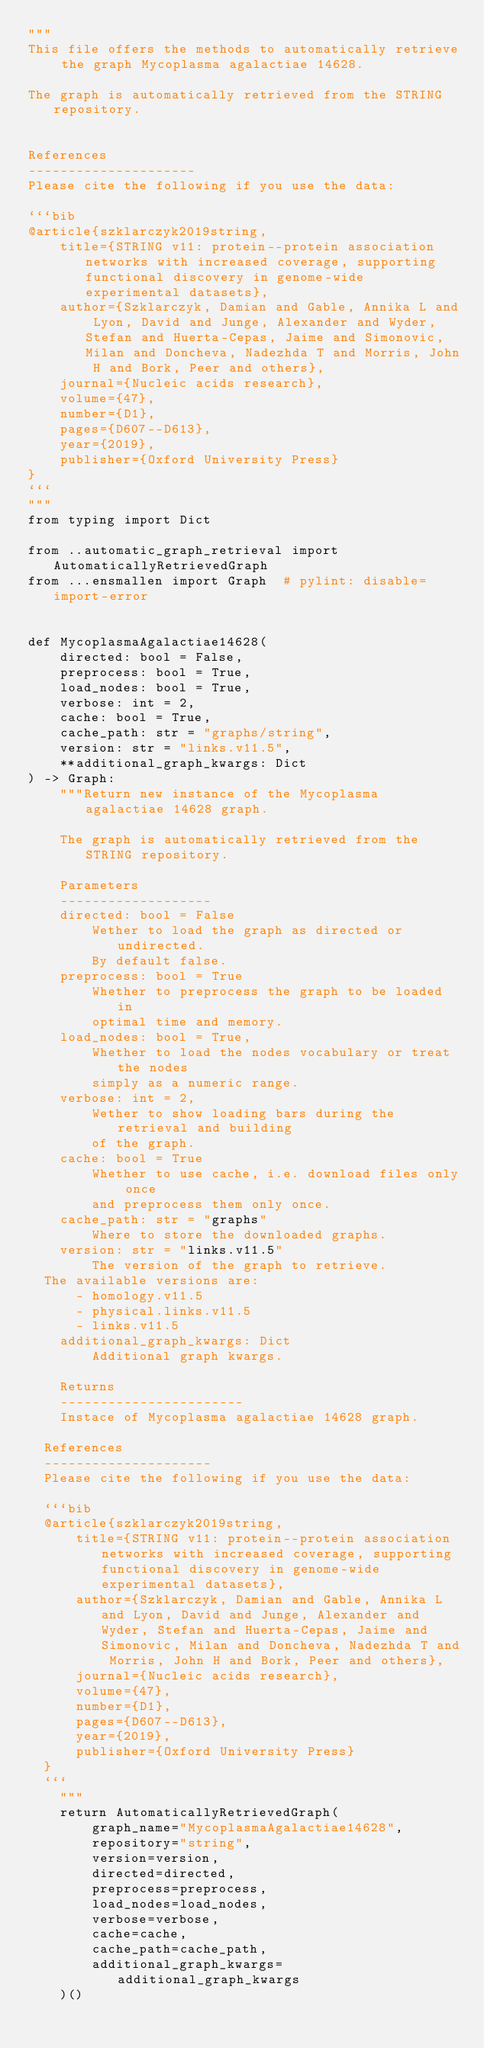Convert code to text. <code><loc_0><loc_0><loc_500><loc_500><_Python_>"""
This file offers the methods to automatically retrieve the graph Mycoplasma agalactiae 14628.

The graph is automatically retrieved from the STRING repository. 


References
---------------------
Please cite the following if you use the data:

```bib
@article{szklarczyk2019string,
    title={STRING v11: protein--protein association networks with increased coverage, supporting functional discovery in genome-wide experimental datasets},
    author={Szklarczyk, Damian and Gable, Annika L and Lyon, David and Junge, Alexander and Wyder, Stefan and Huerta-Cepas, Jaime and Simonovic, Milan and Doncheva, Nadezhda T and Morris, John H and Bork, Peer and others},
    journal={Nucleic acids research},
    volume={47},
    number={D1},
    pages={D607--D613},
    year={2019},
    publisher={Oxford University Press}
}
```
"""
from typing import Dict

from ..automatic_graph_retrieval import AutomaticallyRetrievedGraph
from ...ensmallen import Graph  # pylint: disable=import-error


def MycoplasmaAgalactiae14628(
    directed: bool = False,
    preprocess: bool = True,
    load_nodes: bool = True,
    verbose: int = 2,
    cache: bool = True,
    cache_path: str = "graphs/string",
    version: str = "links.v11.5",
    **additional_graph_kwargs: Dict
) -> Graph:
    """Return new instance of the Mycoplasma agalactiae 14628 graph.

    The graph is automatically retrieved from the STRING repository.	

    Parameters
    -------------------
    directed: bool = False
        Wether to load the graph as directed or undirected.
        By default false.
    preprocess: bool = True
        Whether to preprocess the graph to be loaded in 
        optimal time and memory.
    load_nodes: bool = True,
        Whether to load the nodes vocabulary or treat the nodes
        simply as a numeric range.
    verbose: int = 2,
        Wether to show loading bars during the retrieval and building
        of the graph.
    cache: bool = True
        Whether to use cache, i.e. download files only once
        and preprocess them only once.
    cache_path: str = "graphs"
        Where to store the downloaded graphs.
    version: str = "links.v11.5"
        The version of the graph to retrieve.		
	The available versions are:
			- homology.v11.5
			- physical.links.v11.5
			- links.v11.5
    additional_graph_kwargs: Dict
        Additional graph kwargs.

    Returns
    -----------------------
    Instace of Mycoplasma agalactiae 14628 graph.

	References
	---------------------
	Please cite the following if you use the data:
	
	```bib
	@article{szklarczyk2019string,
	    title={STRING v11: protein--protein association networks with increased coverage, supporting functional discovery in genome-wide experimental datasets},
	    author={Szklarczyk, Damian and Gable, Annika L and Lyon, David and Junge, Alexander and Wyder, Stefan and Huerta-Cepas, Jaime and Simonovic, Milan and Doncheva, Nadezhda T and Morris, John H and Bork, Peer and others},
	    journal={Nucleic acids research},
	    volume={47},
	    number={D1},
	    pages={D607--D613},
	    year={2019},
	    publisher={Oxford University Press}
	}
	```
    """
    return AutomaticallyRetrievedGraph(
        graph_name="MycoplasmaAgalactiae14628",
        repository="string",
        version=version,
        directed=directed,
        preprocess=preprocess,
        load_nodes=load_nodes,
        verbose=verbose,
        cache=cache,
        cache_path=cache_path,
        additional_graph_kwargs=additional_graph_kwargs
    )()
</code> 